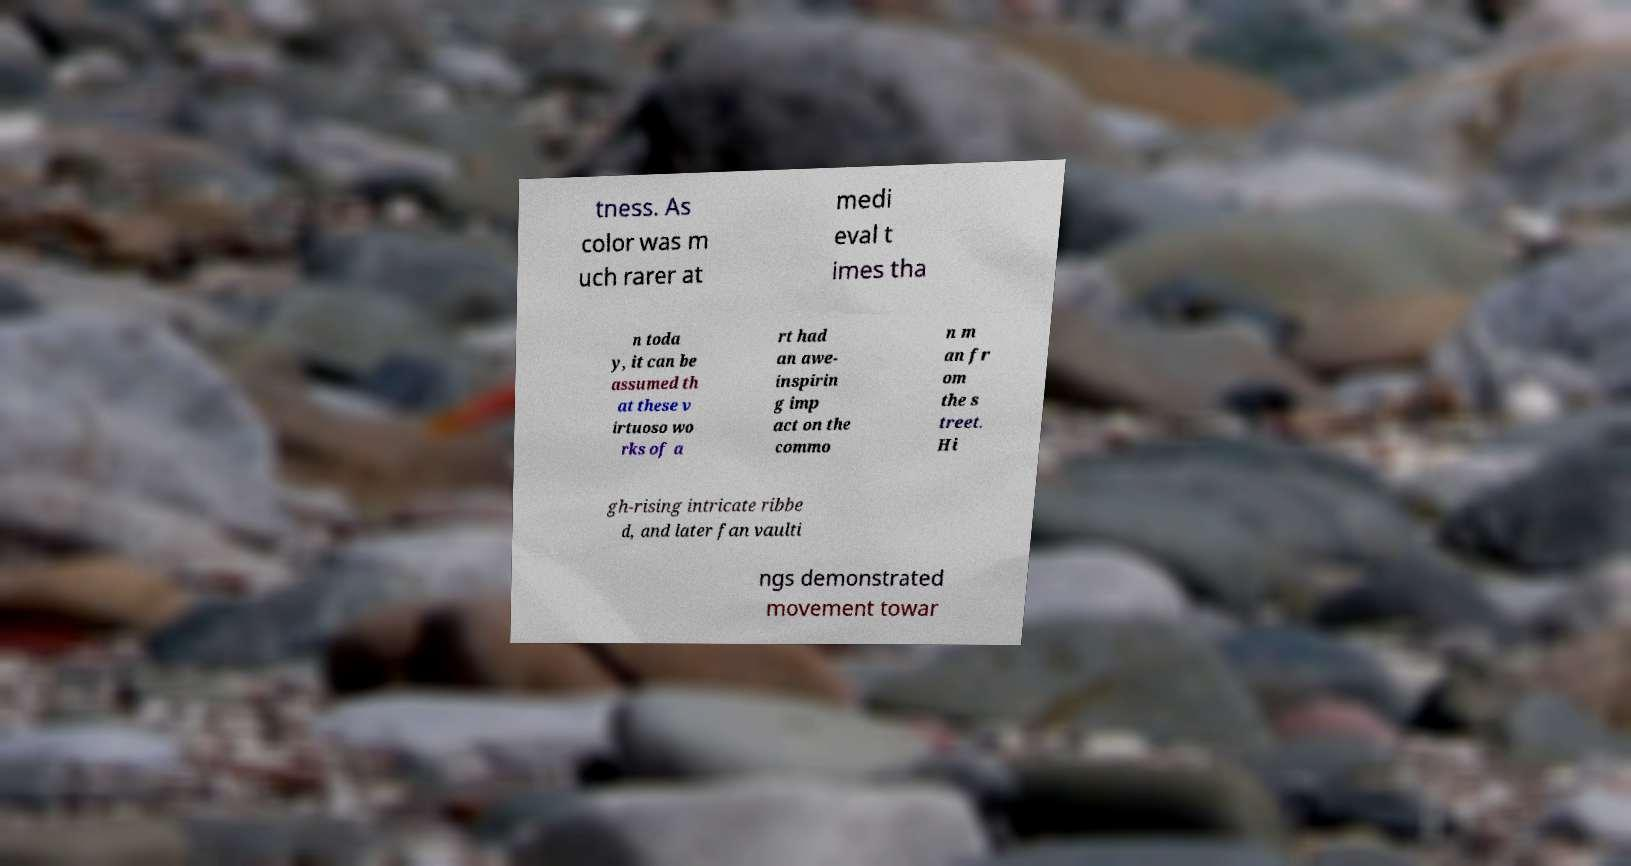Please identify and transcribe the text found in this image. tness. As color was m uch rarer at medi eval t imes tha n toda y, it can be assumed th at these v irtuoso wo rks of a rt had an awe- inspirin g imp act on the commo n m an fr om the s treet. Hi gh-rising intricate ribbe d, and later fan vaulti ngs demonstrated movement towar 